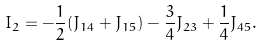Convert formula to latex. <formula><loc_0><loc_0><loc_500><loc_500>I _ { 2 } = - \frac { 1 } { 2 } ( J _ { 1 4 } + J _ { 1 5 } ) - \frac { 3 } { 4 } J _ { 2 3 } + \frac { 1 } { 4 } J _ { 4 5 } .</formula> 